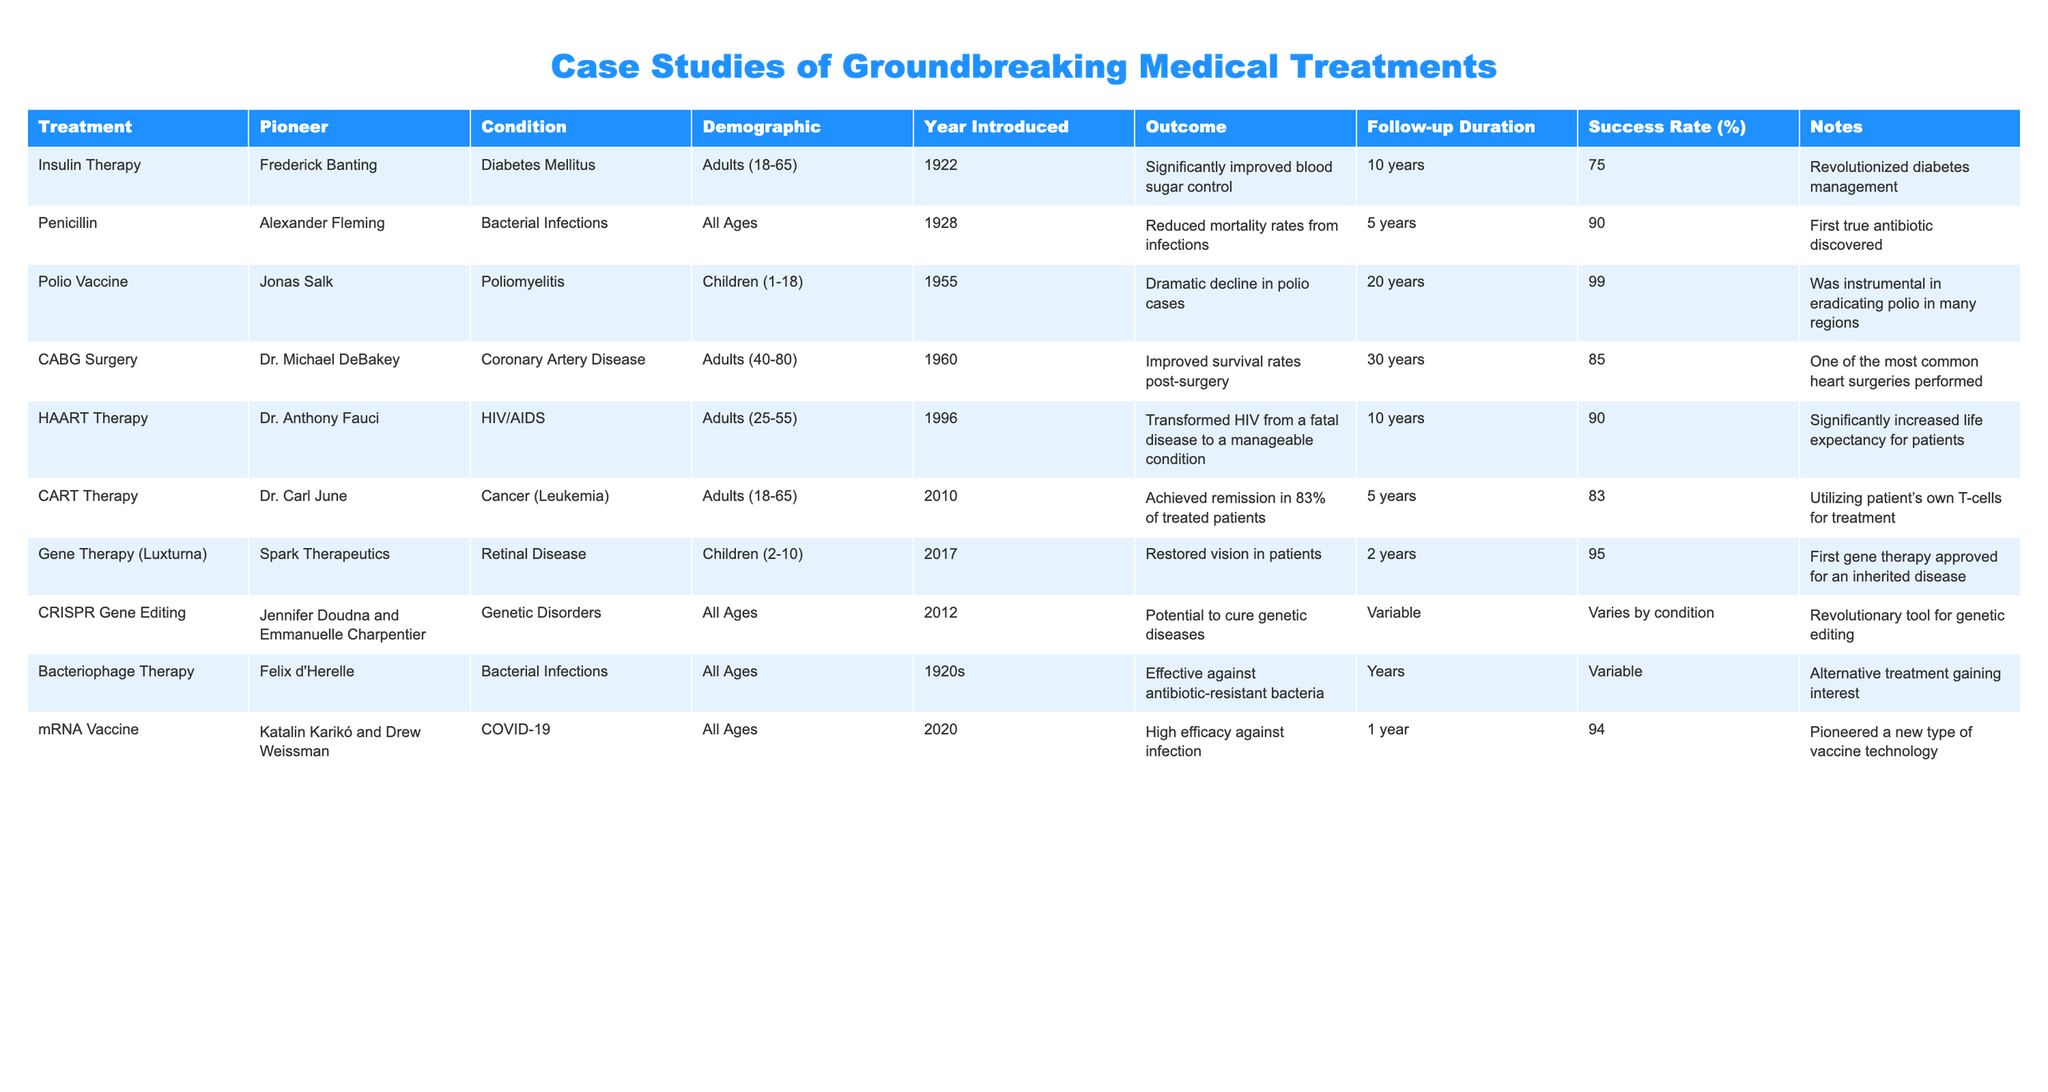What treatment had the highest success rate? The success rates for the treatments are: Insulin Therapy (75%), Penicillin (90%), Polio Vaccine (99%), CABG Surgery (85%), HAART Therapy (90%), CART Therapy (83%), Gene Therapy (Luxturna) (95%), CRISPR Gene Editing (Varies), Bacteriophage Therapy (Variable), and mRNA Vaccine (94%). The Polio Vaccine has the highest success rate at 99%.
Answer: Polio Vaccine How long was the follow-up duration for CABG Surgery? The follow-up duration for CABG Surgery is stated in the table as 30 years.
Answer: 30 years Which pioneer is associated with the development of the HAART Therapy? The table shows that HAART Therapy was pioneered by Dr. Anthony Fauci.
Answer: Dr. Anthony Fauci What was the outcome of the CRISPR Gene Editing? The outcome for CRISPR Gene Editing indicates it has the potential to cure genetic diseases, according to the table.
Answer: Potential to cure genetic diseases Is the mRNA Vaccine effective across all age groups? The mRNA Vaccine was introduced for all ages, and its efficacy is noted as high against infection. Therefore, it can be considered effective across all age groups.
Answer: Yes What is the average success rate for treatments introduced before 2000? The success rates for the treatments before 2000 are: Insulin Therapy (75%), Penicillin (90%), Polio Vaccine (99%), CABG Surgery (85%), and Bacteriophage Therapy (Variable). The sum of known rates is 75 + 90 + 99 + 85 = 349. There are 4 known treatments, so the average is 349/4 = 87.25.
Answer: 87.25 How many treatments have a follow-up duration longer than 10 years? Examining the follow-up durations: Insulin Therapy (10 years), Penicillin (5 years), Polio Vaccine (20 years), CABG Surgery (30 years), HAART Therapy (10 years), CART Therapy (5 years), Gene Therapy (2 years), CRISPR Gene Editing (Variable), Bacteriophage Therapy (Years), mRNA Vaccine (1 year). Only Polio Vaccine and CABG Surgery have follow-up durations longer than 10 years, totaling 2 treatments.
Answer: 2 What condition was treated using Gene Therapy (Luxturna)? The table indicates that Gene Therapy (Luxturna) treats Retinal Disease.
Answer: Retinal Disease Which treatment has a follow-up duration shorter than 5 years? The treatments with follow-up durations shorter than 5 years are Penicillin (5 years), CART Therapy (5 years), Gene Therapy (2 years), and mRNA Vaccine (1 year). The treatments with durations of less than 5 years are Gene Therapy and mRNA Vaccine.
Answer: Gene Therapy and mRNA Vaccine Which treatments were introduced in the 2010s? Looking at the data, CART Therapy was introduced in 2010 and Gene Therapy (Luxturna) in 2017. Therefore, there are two relevant treatments from the 2010s.
Answer: CART Therapy and Gene Therapy (Luxturna) 